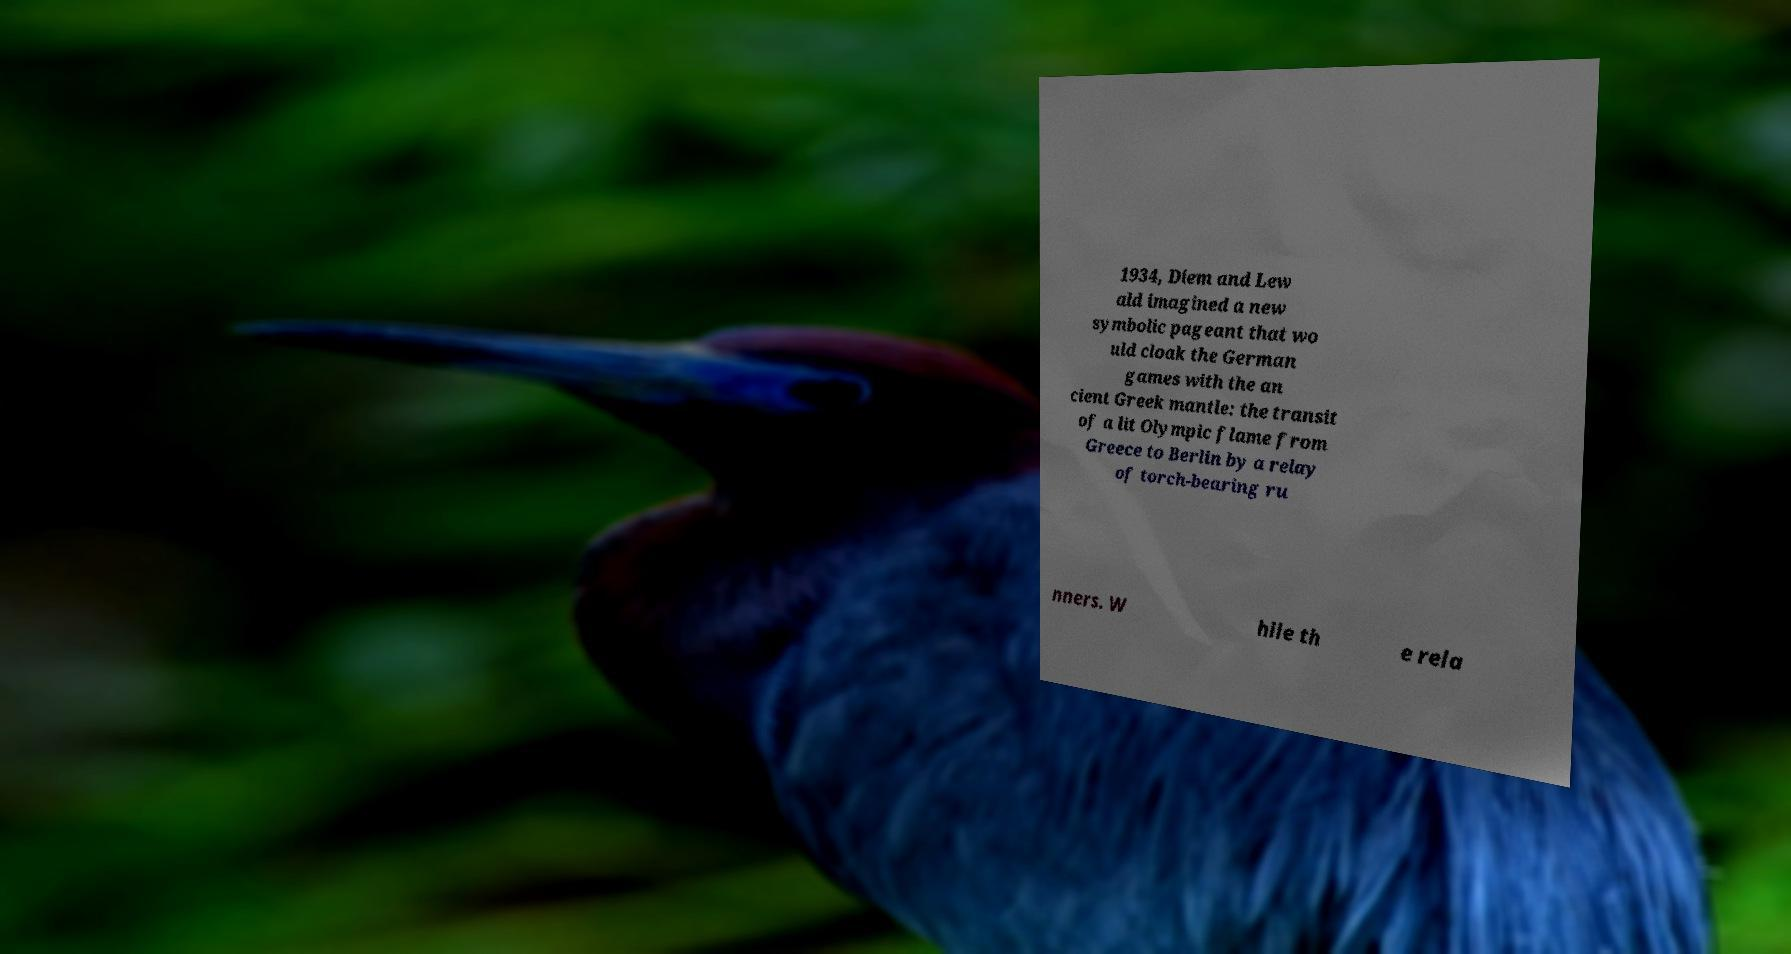Could you assist in decoding the text presented in this image and type it out clearly? 1934, Diem and Lew ald imagined a new symbolic pageant that wo uld cloak the German games with the an cient Greek mantle: the transit of a lit Olympic flame from Greece to Berlin by a relay of torch-bearing ru nners. W hile th e rela 